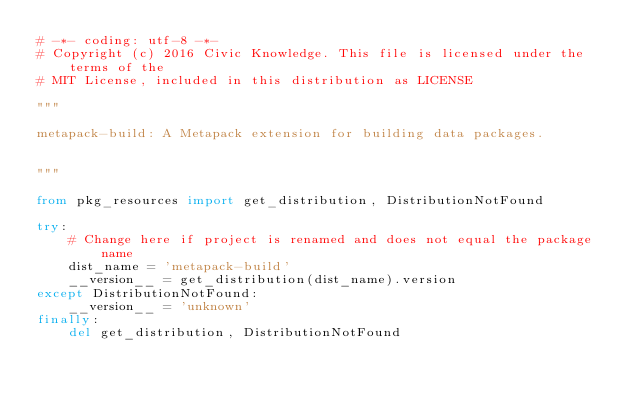Convert code to text. <code><loc_0><loc_0><loc_500><loc_500><_Python_># -*- coding: utf-8 -*-
# Copyright (c) 2016 Civic Knowledge. This file is licensed under the terms of the
# MIT License, included in this distribution as LICENSE

"""

metapack-build: A Metapack extension for building data packages.


"""

from pkg_resources import get_distribution, DistributionNotFound

try:
    # Change here if project is renamed and does not equal the package name
    dist_name = 'metapack-build'
    __version__ = get_distribution(dist_name).version
except DistributionNotFound:
    __version__ = 'unknown'
finally:
    del get_distribution, DistributionNotFound
</code> 